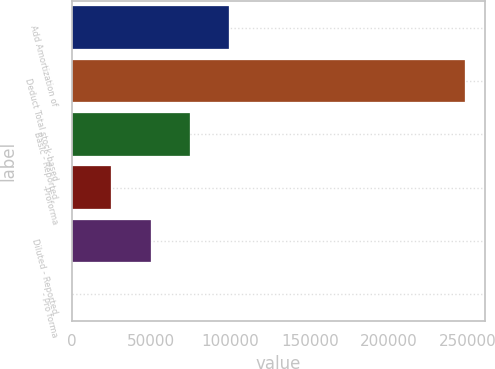Convert chart to OTSL. <chart><loc_0><loc_0><loc_500><loc_500><bar_chart><fcel>Add Amortization of<fcel>Deduct Total stock-based<fcel>Basic - Reported<fcel>-Proforma<fcel>Diluted - Reported<fcel>- Pro forma<nl><fcel>99304.4<fcel>248260<fcel>74478.4<fcel>24826.5<fcel>49652.5<fcel>0.61<nl></chart> 